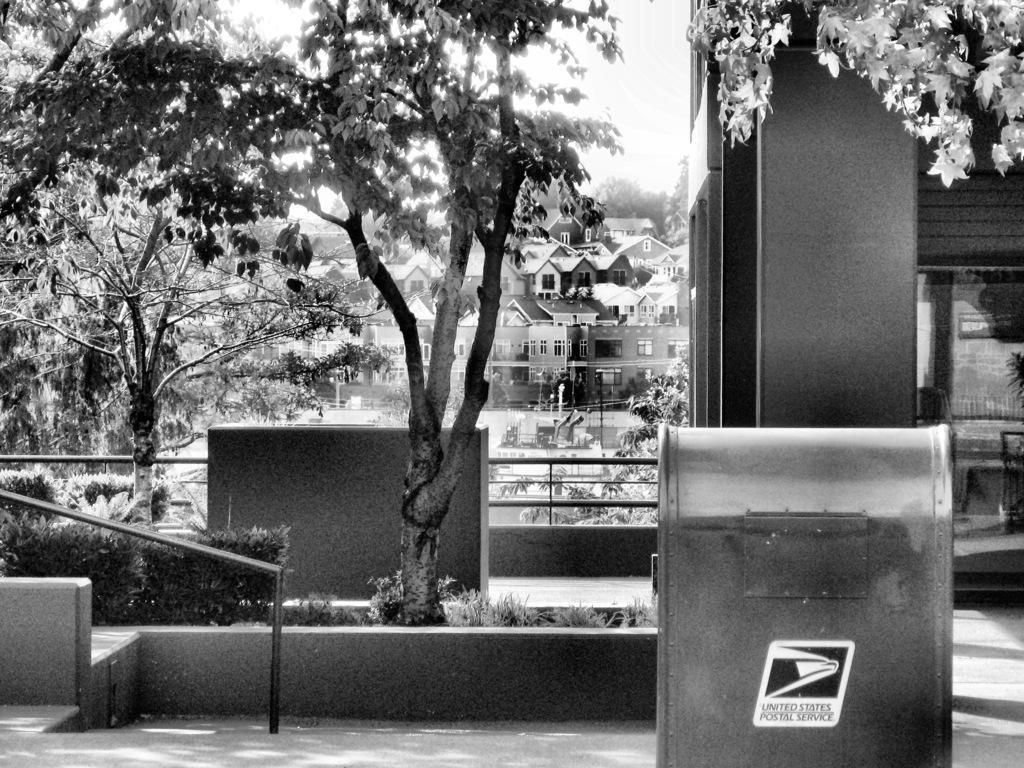Please provide a concise description of this image. In this picture there are trees in the left corner. There is box with some text in the right corner. There are some buildings in the background. The floor is at the bottom and The sky is at the top. 